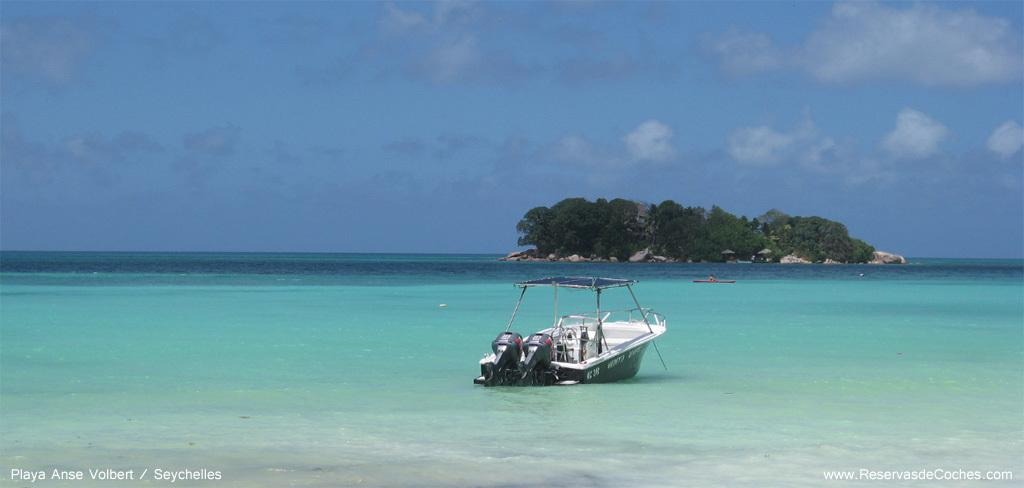What is the main subject of the image? There is a boat on the water in the image. What can be seen in the background of the image? There are trees and the sky with clouds visible in the background of the image. How many boats are present in the image? There are two boats in the image. Is there any text in the image? Yes, there is text at the bottom of the image. What type of wrench is being used to fix the boat's stomach in the image? There is no wrench or boat's stomach present in the image; it features a boat on the water with another boat in the background. What flavor of pie is being served on the boat in the image? There is no pie present in the image; it only shows a boat on the water with another boat in the background. 